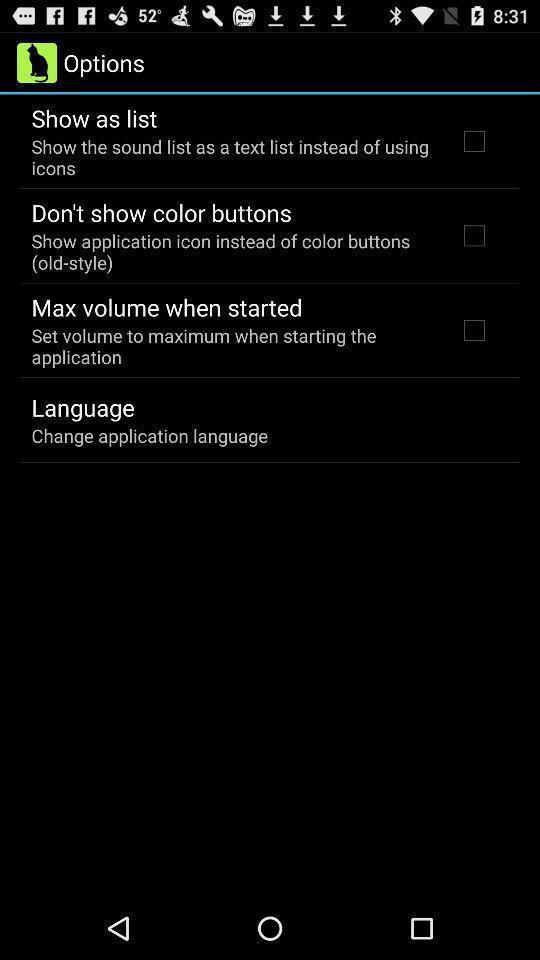Describe the content in this image. Screen displaying multiple setting options. 